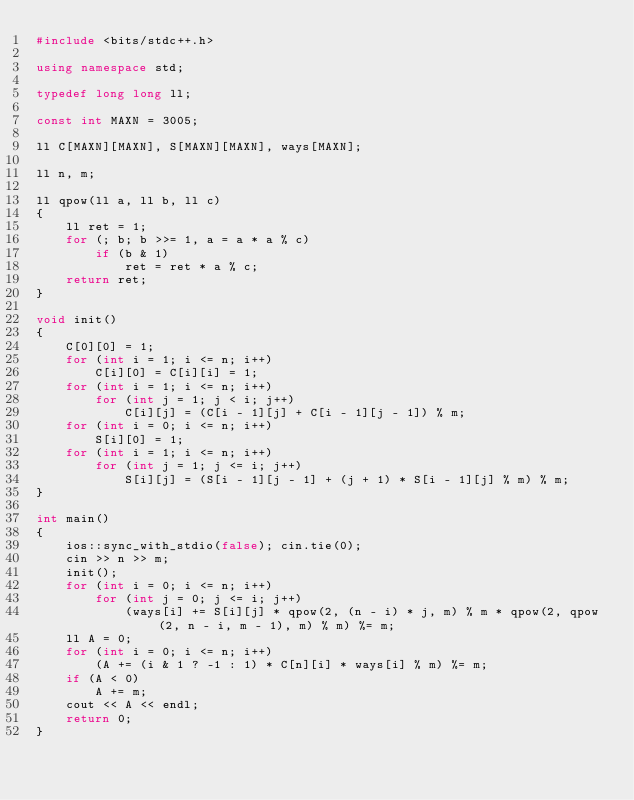Convert code to text. <code><loc_0><loc_0><loc_500><loc_500><_C++_>#include <bits/stdc++.h>

using namespace std;

typedef long long ll;

const int MAXN = 3005;

ll C[MAXN][MAXN], S[MAXN][MAXN], ways[MAXN];

ll n, m;

ll qpow(ll a, ll b, ll c)
{
	ll ret = 1;
	for (; b; b >>= 1, a = a * a % c)
		if (b & 1)
			ret = ret * a % c;
	return ret;
}

void init()
{
	C[0][0] = 1;
	for (int i = 1; i <= n; i++)
		C[i][0] = C[i][i] = 1;
	for (int i = 1; i <= n; i++)
		for (int j = 1; j < i; j++)
			C[i][j] = (C[i - 1][j] + C[i - 1][j - 1]) % m;
	for (int i = 0; i <= n; i++)
		S[i][0] = 1;
	for (int i = 1; i <= n; i++)
		for (int j = 1; j <= i; j++)
			S[i][j] = (S[i - 1][j - 1] + (j + 1) * S[i - 1][j] % m) % m;
}

int main()
{
	ios::sync_with_stdio(false); cin.tie(0);
	cin >> n >> m;
	init();
	for (int i = 0; i <= n; i++)
		for (int j = 0; j <= i; j++)
			(ways[i] += S[i][j] * qpow(2, (n - i) * j, m) % m * qpow(2, qpow(2, n - i, m - 1), m) % m) %= m;
	ll A = 0;
	for (int i = 0; i <= n; i++)
		(A += (i & 1 ? -1 : 1) * C[n][i] * ways[i] % m) %= m;
	if (A < 0)
		A += m;
	cout << A << endl;
	return 0;	
}
</code> 